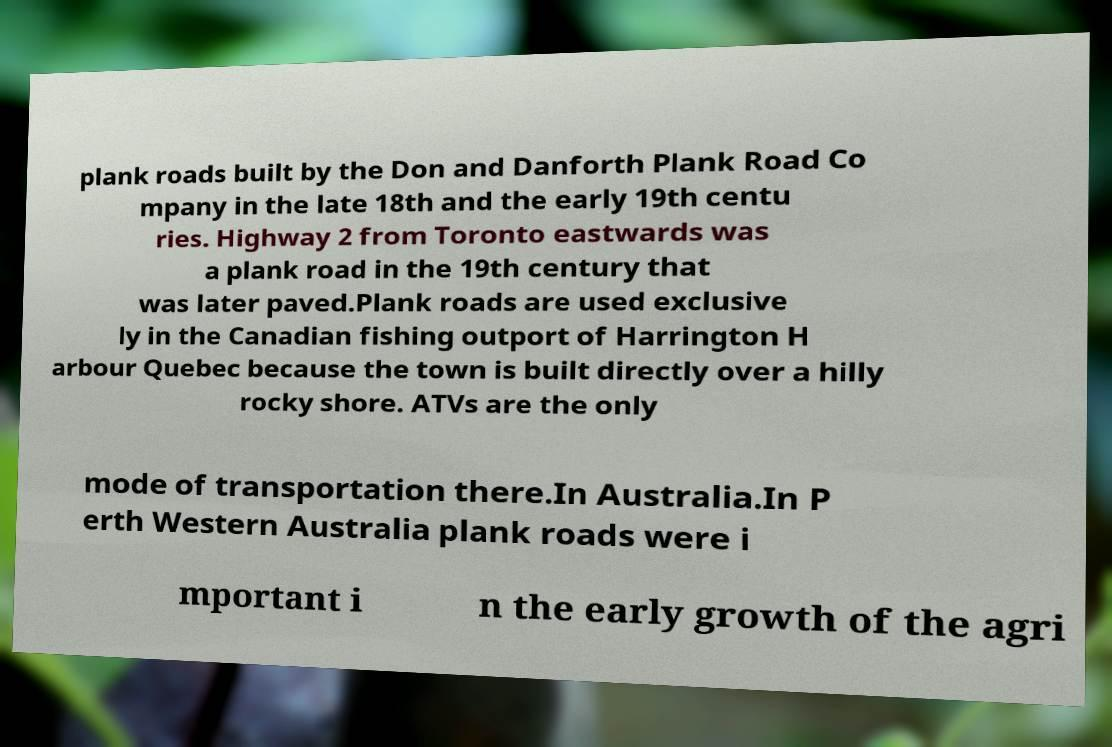Please read and relay the text visible in this image. What does it say? plank roads built by the Don and Danforth Plank Road Co mpany in the late 18th and the early 19th centu ries. Highway 2 from Toronto eastwards was a plank road in the 19th century that was later paved.Plank roads are used exclusive ly in the Canadian fishing outport of Harrington H arbour Quebec because the town is built directly over a hilly rocky shore. ATVs are the only mode of transportation there.In Australia.In P erth Western Australia plank roads were i mportant i n the early growth of the agri 